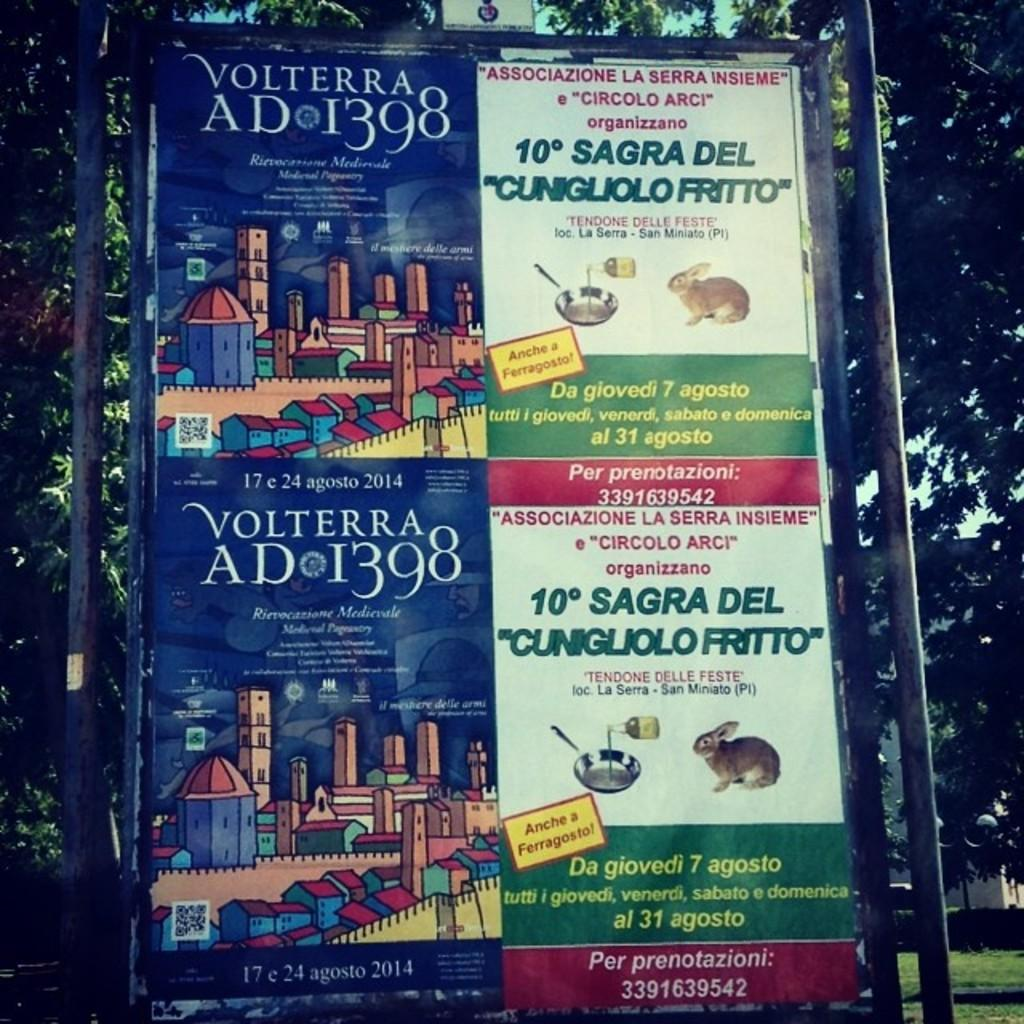<image>
Describe the image concisely. A signboard with adverts for Volterra and Cunigliolo Fritto. 